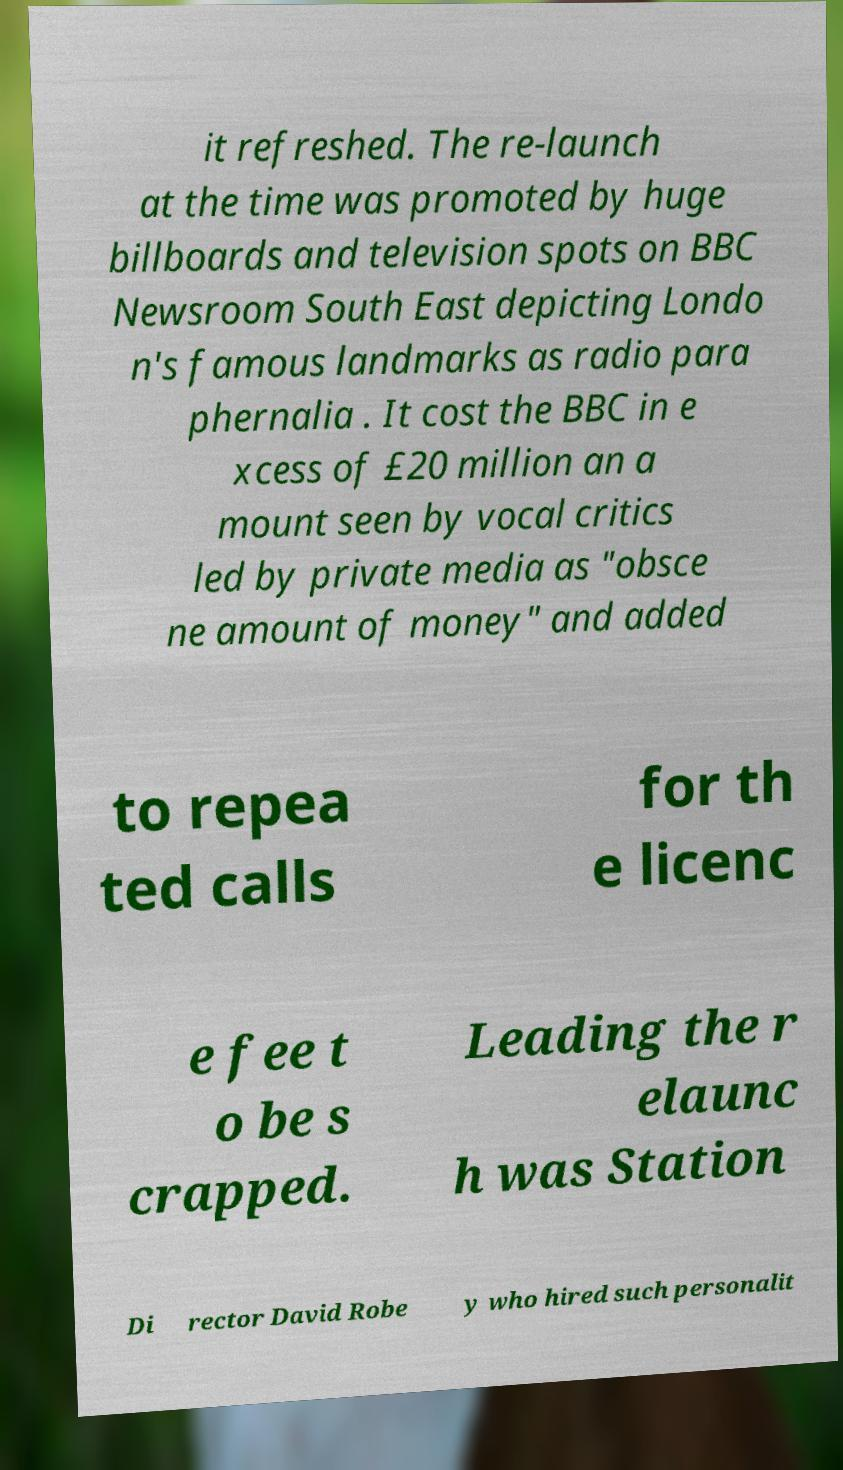There's text embedded in this image that I need extracted. Can you transcribe it verbatim? it refreshed. The re-launch at the time was promoted by huge billboards and television spots on BBC Newsroom South East depicting Londo n's famous landmarks as radio para phernalia . It cost the BBC in e xcess of £20 million an a mount seen by vocal critics led by private media as "obsce ne amount of money" and added to repea ted calls for th e licenc e fee t o be s crapped. Leading the r elaunc h was Station Di rector David Robe y who hired such personalit 